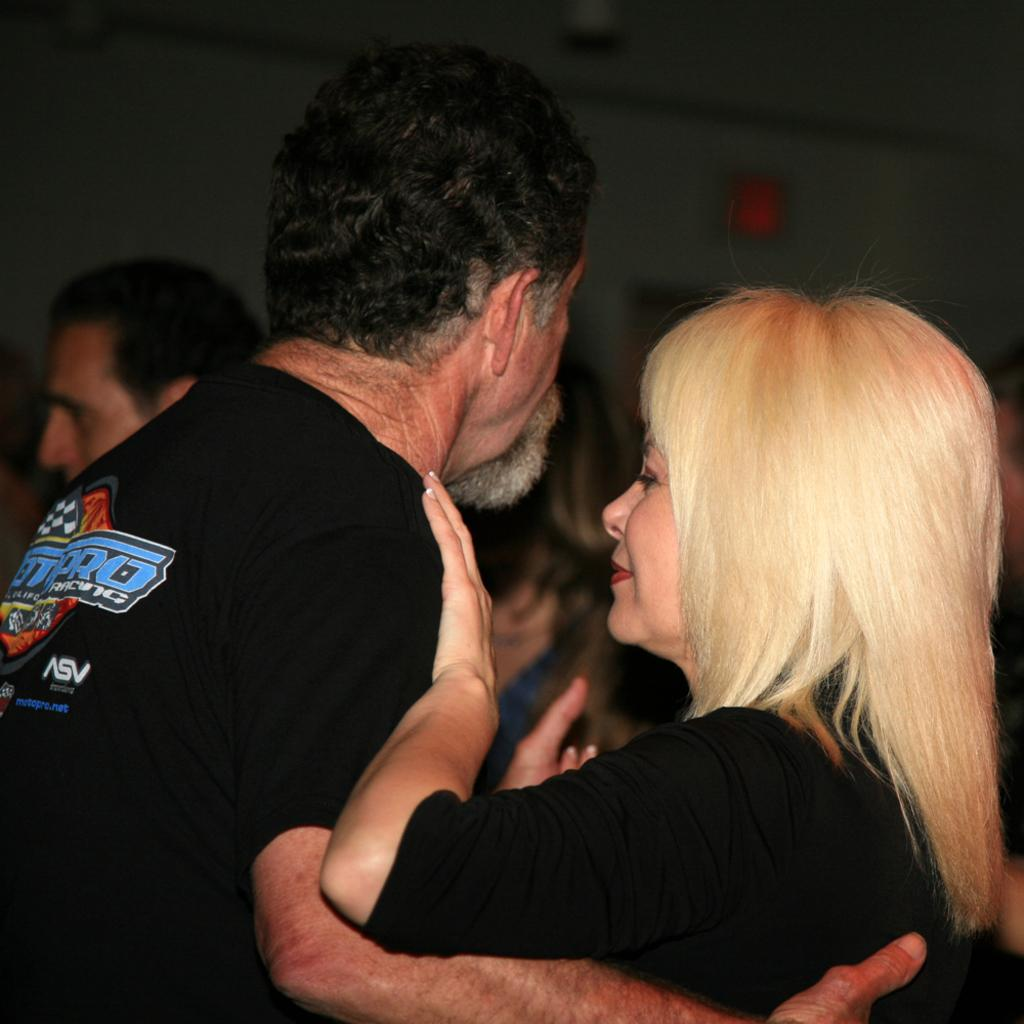<image>
Render a clear and concise summary of the photo. A woman dancing with a man who is wearing shirt with an ASV advertisement on his back. 